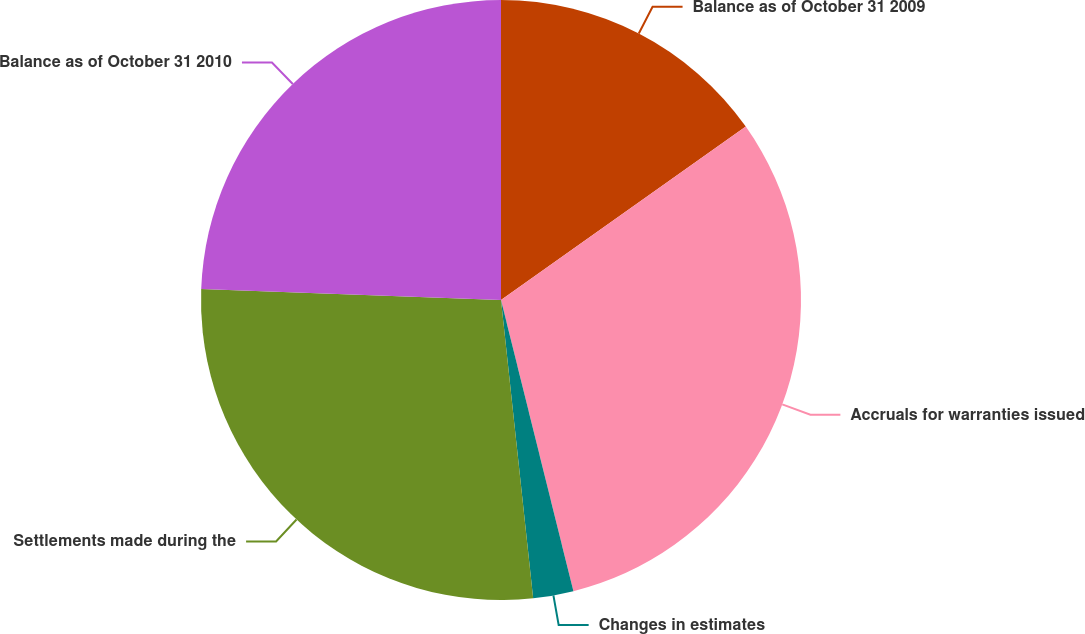Convert chart. <chart><loc_0><loc_0><loc_500><loc_500><pie_chart><fcel>Balance as of October 31 2009<fcel>Accruals for warranties issued<fcel>Changes in estimates<fcel>Settlements made during the<fcel>Balance as of October 31 2010<nl><fcel>15.19%<fcel>30.93%<fcel>2.17%<fcel>27.29%<fcel>24.42%<nl></chart> 